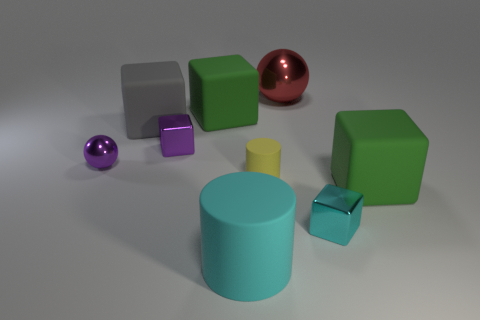Subtract all cyan metal cubes. How many cubes are left? 4 Subtract all purple blocks. How many blocks are left? 4 Subtract all blue blocks. Subtract all purple cylinders. How many blocks are left? 5 Add 1 purple blocks. How many objects exist? 10 Subtract all balls. How many objects are left? 7 Add 5 metallic balls. How many metallic balls are left? 7 Add 2 large yellow blocks. How many large yellow blocks exist? 2 Subtract 1 cyan cylinders. How many objects are left? 8 Subtract all big matte cubes. Subtract all big green things. How many objects are left? 4 